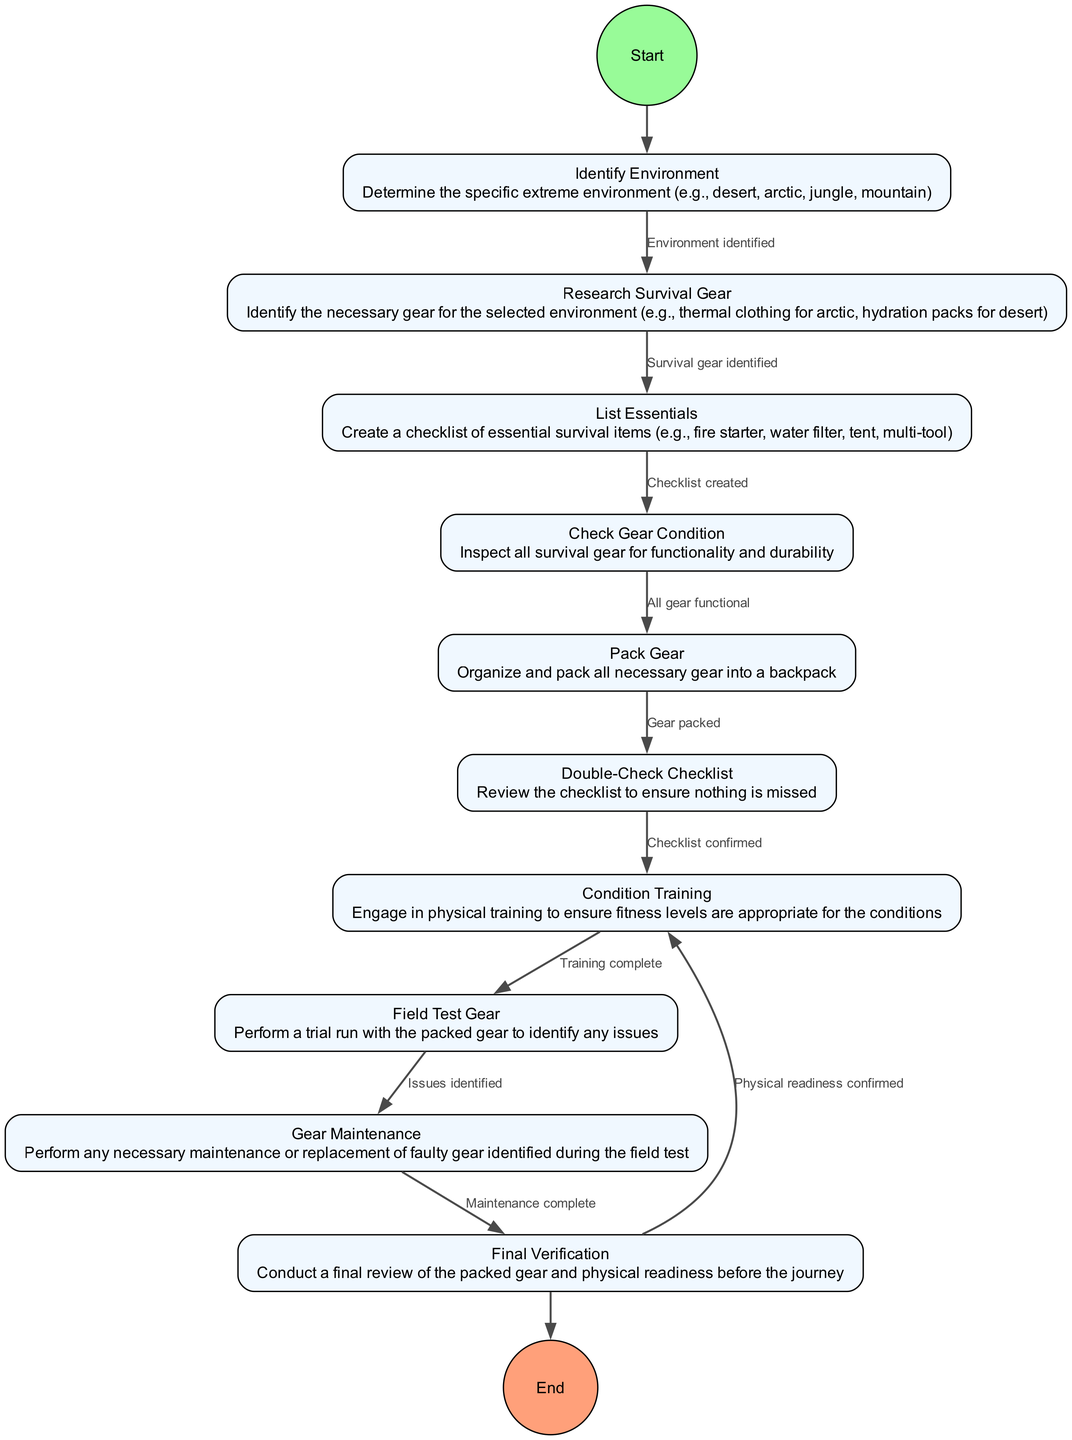What is the start point of the diagram? The start point is labeled "Identify Environment", as indicated by its positioning as the first node in the flow diagram.
Answer: Identify Environment How many activities are present in the diagram? By counting each node labeled as an activity within the diagram, there are ten distinct activities outlined.
Answer: 10 Which activity directly follows "Check Gear Condition"? The diagram indicates that the activity "Pack Gear" follows "Check Gear Condition" according to the directed edges connecting these nodes.
Answer: Pack Gear What is the condition to proceed from "Research Survival Gear" to "List Essentials"? The transition from "Research Survival Gear" to "List Essentials" occurs when the condition "Survival gear identified" is met, as marked by the directed edge.
Answer: Survival gear identified What is the last activity before reaching the end point? The penultimate activity is "Final Verification", which is the last one before the flow concludes at the end point represented in the diagram as "End".
Answer: Final Verification What happens after the "Condition Training" activity is complete? Upon completion of "Condition Training", the diagram indicates that the next step is "Field Test Gear", showing the progression based on the flow of activities.
Answer: Field Test Gear How many transitions are indicated in the diagram? There are nine transitions connecting the activities, as represented by the directed edges leading from one activity to another.
Answer: 9 What activity requires maintenance based on the diagram's flow? "Gear Maintenance" is the activity requiring maintenance after any issues are identified during the "Field Test Gear".
Answer: Gear Maintenance What condition must be confirmed to move from "Double-Check Checklist" to "Condition Training"? The condition required to advance to "Condition Training" is that the checklist must be "Checklist confirmed".
Answer: Checklist confirmed 